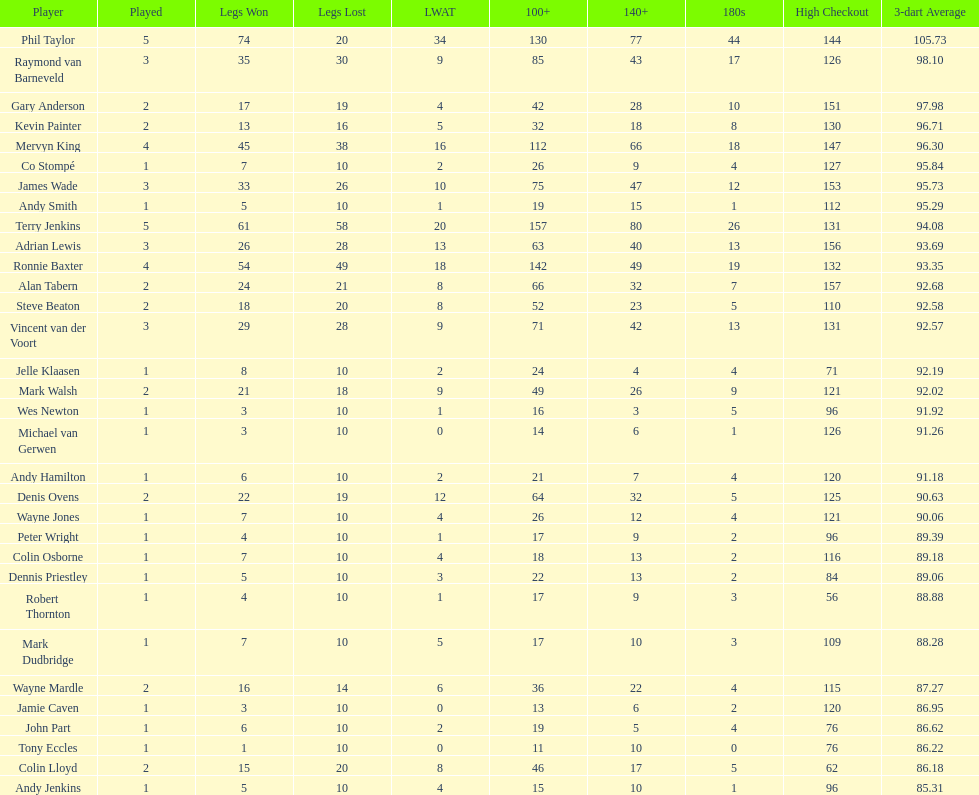Enumerate all the players with a high checkout of 13 Terry Jenkins, Vincent van der Voort. 